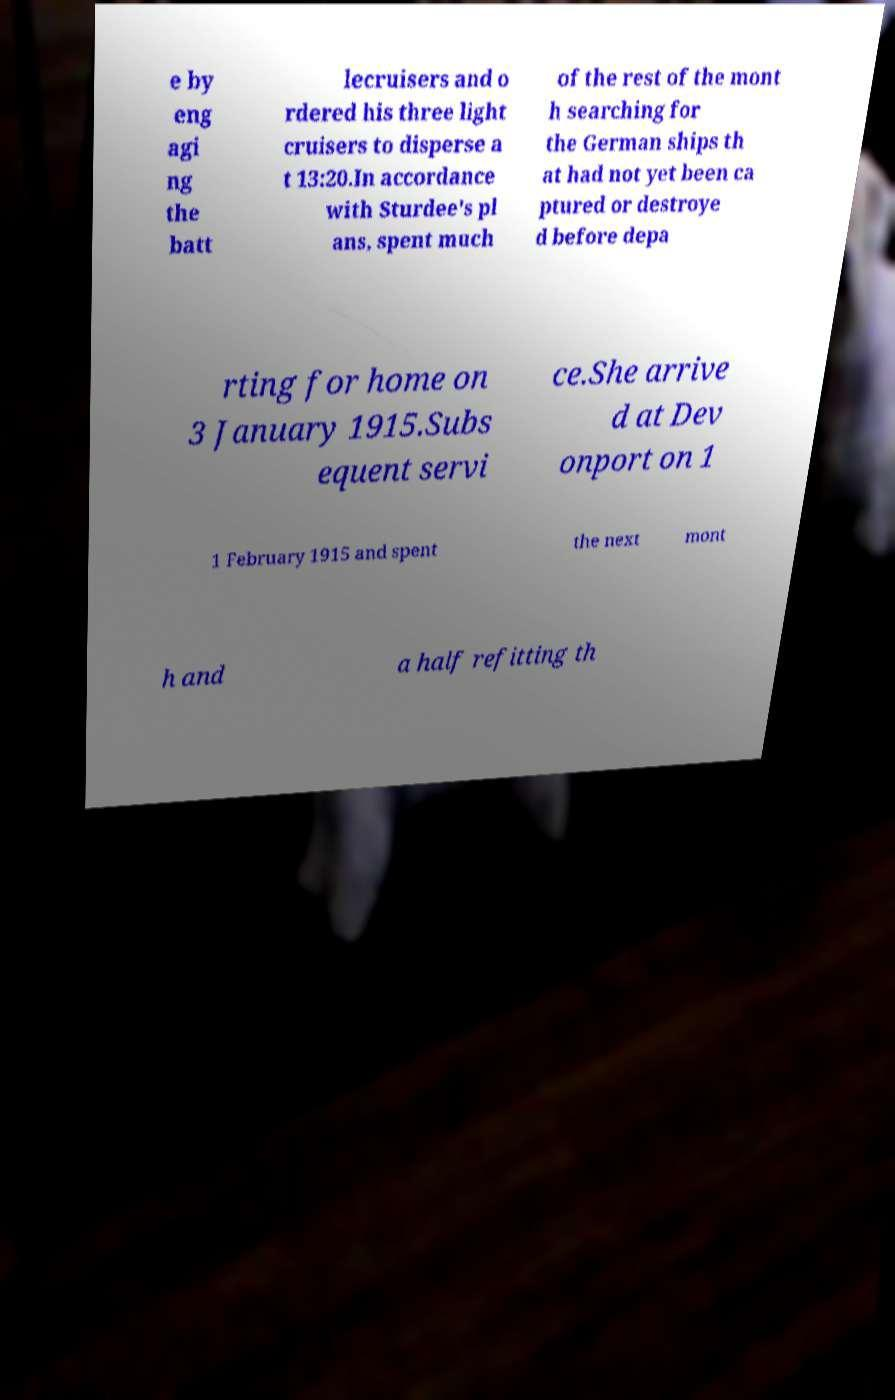Please identify and transcribe the text found in this image. e by eng agi ng the batt lecruisers and o rdered his three light cruisers to disperse a t 13:20.In accordance with Sturdee's pl ans, spent much of the rest of the mont h searching for the German ships th at had not yet been ca ptured or destroye d before depa rting for home on 3 January 1915.Subs equent servi ce.She arrive d at Dev onport on 1 1 February 1915 and spent the next mont h and a half refitting th 